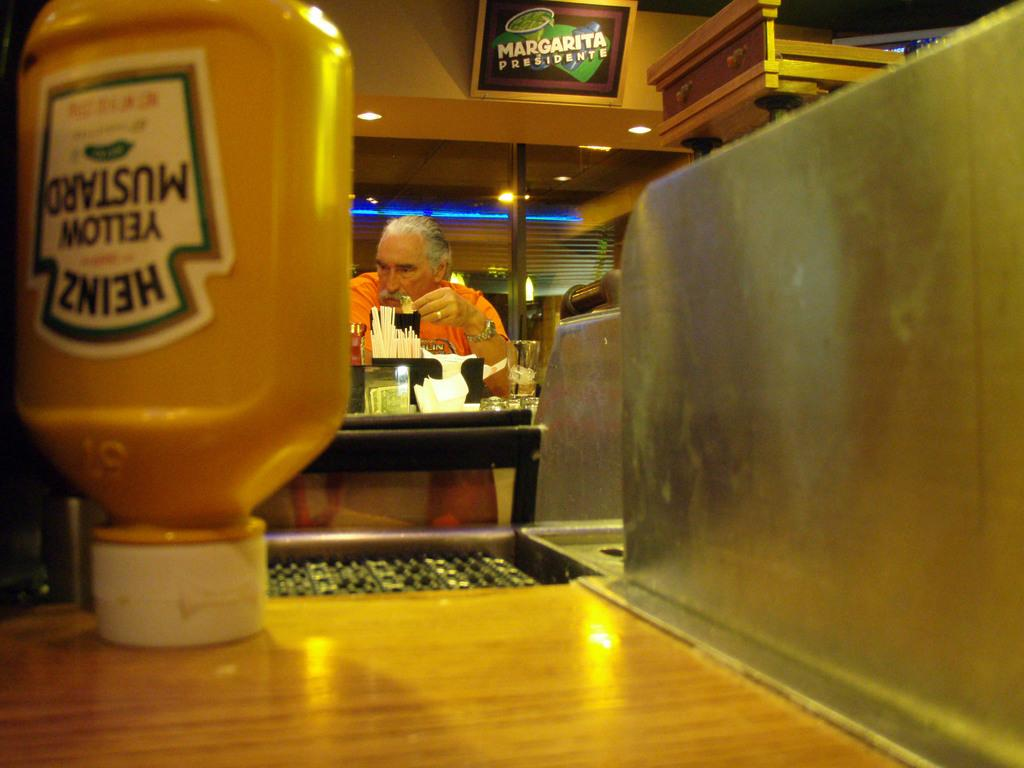<image>
Present a compact description of the photo's key features. a closeup of an upside down Heinz yellow mustard container and MARGARITA PRESIDENTE sign  on the upper wall. 